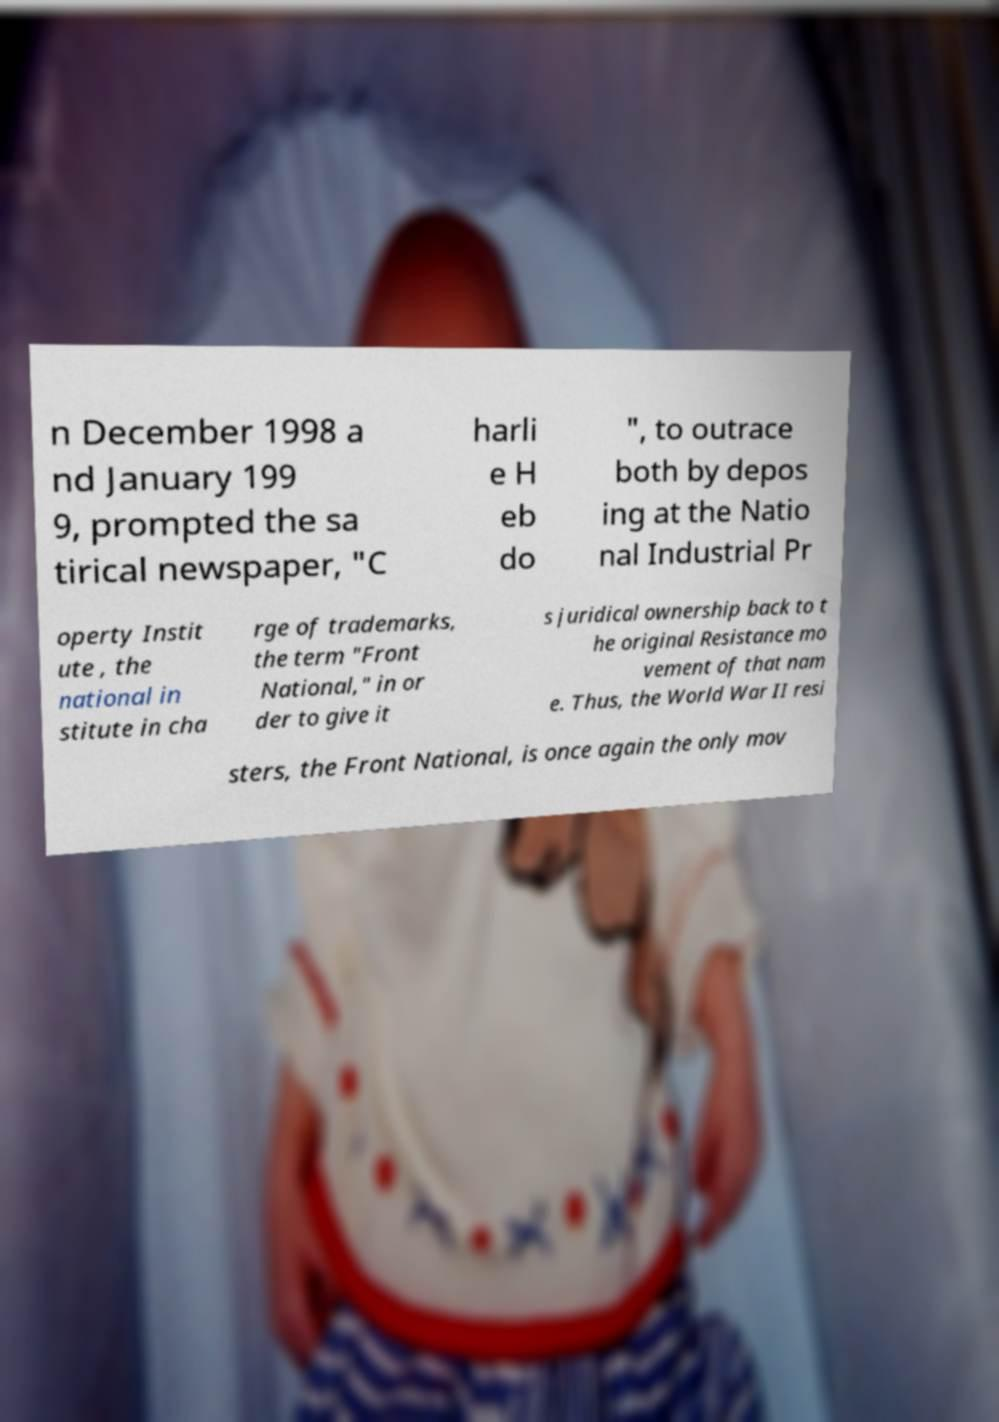For documentation purposes, I need the text within this image transcribed. Could you provide that? n December 1998 a nd January 199 9, prompted the sa tirical newspaper, "C harli e H eb do ", to outrace both by depos ing at the Natio nal Industrial Pr operty Instit ute , the national in stitute in cha rge of trademarks, the term "Front National," in or der to give it s juridical ownership back to t he original Resistance mo vement of that nam e. Thus, the World War II resi sters, the Front National, is once again the only mov 